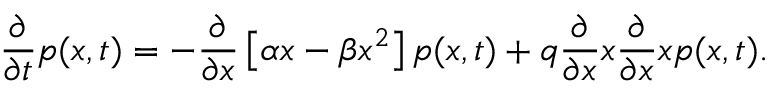<formula> <loc_0><loc_0><loc_500><loc_500>\frac { \partial } { \partial t } p ( x , t ) = - \frac { \partial } { \partial x } \left [ \alpha x - \beta x ^ { 2 } \right ] p ( x , t ) + q \frac { \partial } { \partial x } x \frac { \partial } { \partial x } x p ( x , t ) .</formula> 